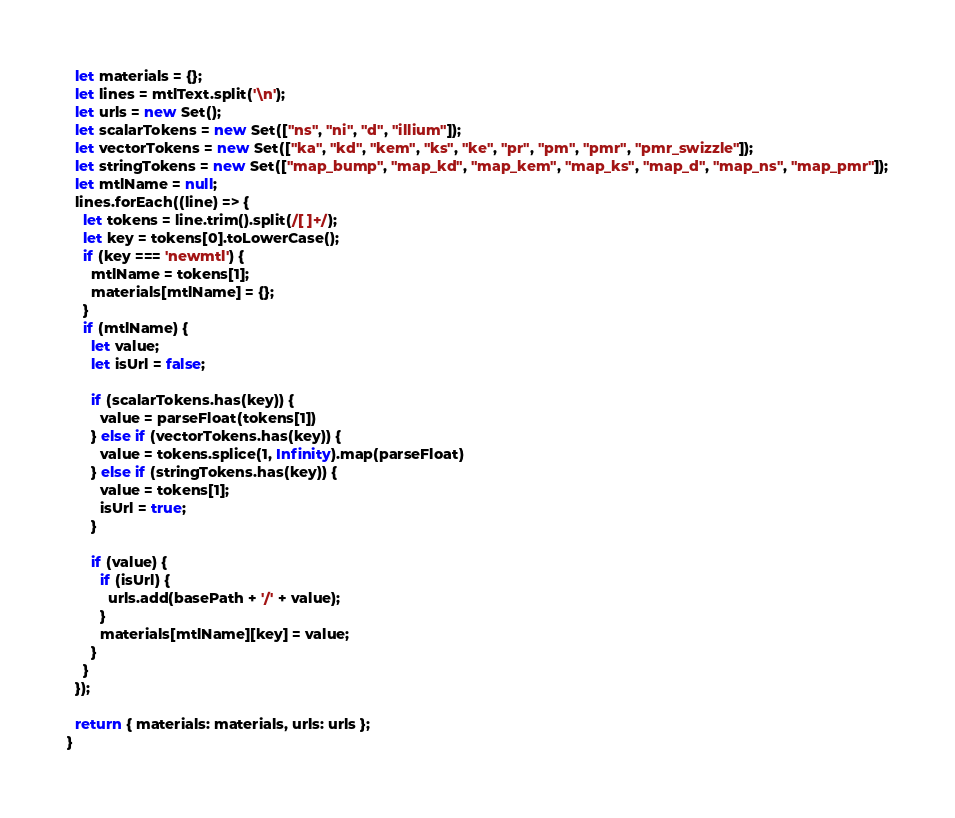Convert code to text. <code><loc_0><loc_0><loc_500><loc_500><_JavaScript_>  let materials = {};
  let lines = mtlText.split('\n');
  let urls = new Set();
  let scalarTokens = new Set(["ns", "ni", "d", "illium"]);
  let vectorTokens = new Set(["ka", "kd", "kem", "ks", "ke", "pr", "pm", "pmr", "pmr_swizzle"]);
  let stringTokens = new Set(["map_bump", "map_kd", "map_kem", "map_ks", "map_d", "map_ns", "map_pmr"]);
  let mtlName = null;
  lines.forEach((line) => {
    let tokens = line.trim().split(/[ ]+/);
    let key = tokens[0].toLowerCase();
    if (key === 'newmtl') {
      mtlName = tokens[1];
      materials[mtlName] = {};
    }
    if (mtlName) {
      let value;
      let isUrl = false;

      if (scalarTokens.has(key)) {
        value = parseFloat(tokens[1])
      } else if (vectorTokens.has(key)) {
        value = tokens.splice(1, Infinity).map(parseFloat)
      } else if (stringTokens.has(key)) {
        value = tokens[1];
        isUrl = true;
      }

      if (value) {
        if (isUrl) {
          urls.add(basePath + '/' + value);
        }
        materials[mtlName][key] = value;
      }
    }
  });

  return { materials: materials, urls: urls };
}</code> 